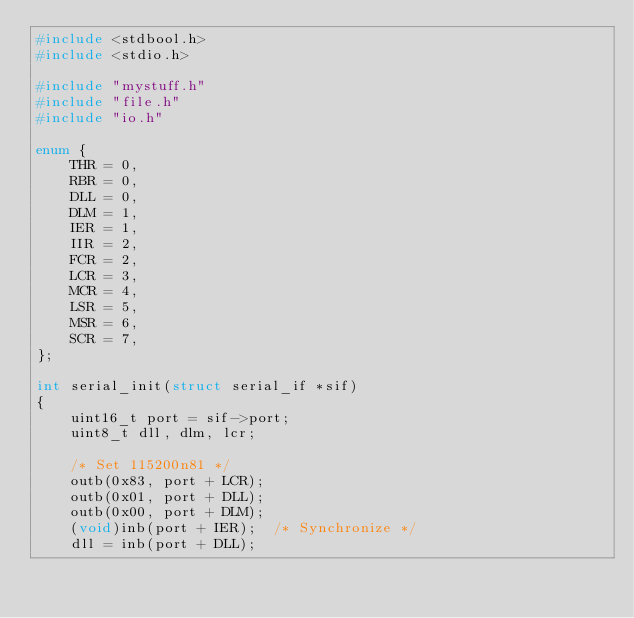<code> <loc_0><loc_0><loc_500><loc_500><_C_>#include <stdbool.h>
#include <stdio.h>

#include "mystuff.h"
#include "file.h"
#include "io.h"

enum {
    THR = 0,
    RBR = 0,
    DLL = 0,
    DLM = 1,
    IER = 1,
    IIR = 2,
    FCR = 2,
    LCR = 3,
    MCR = 4,
    LSR = 5,
    MSR = 6,
    SCR = 7,
};

int serial_init(struct serial_if *sif)
{
    uint16_t port = sif->port;
    uint8_t dll, dlm, lcr;

    /* Set 115200n81 */
    outb(0x83, port + LCR);
    outb(0x01, port + DLL);
    outb(0x00, port + DLM);
    (void)inb(port + IER);	/* Synchronize */
    dll = inb(port + DLL);</code> 